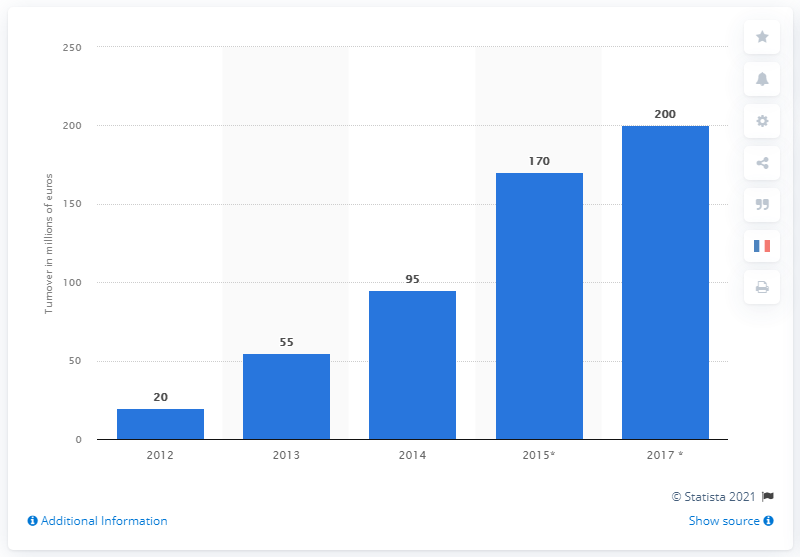Give some essential details in this illustration. According to estimates, the turnover of French companies in the drone sector reached approximately 200 million euros in 2017. 